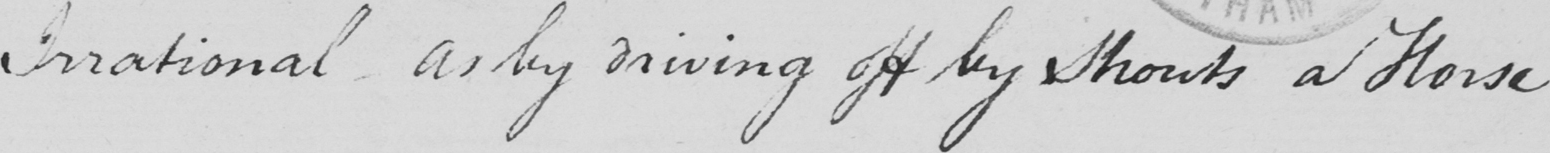What does this handwritten line say? Irrational as by driving off by Shouts a Horse 